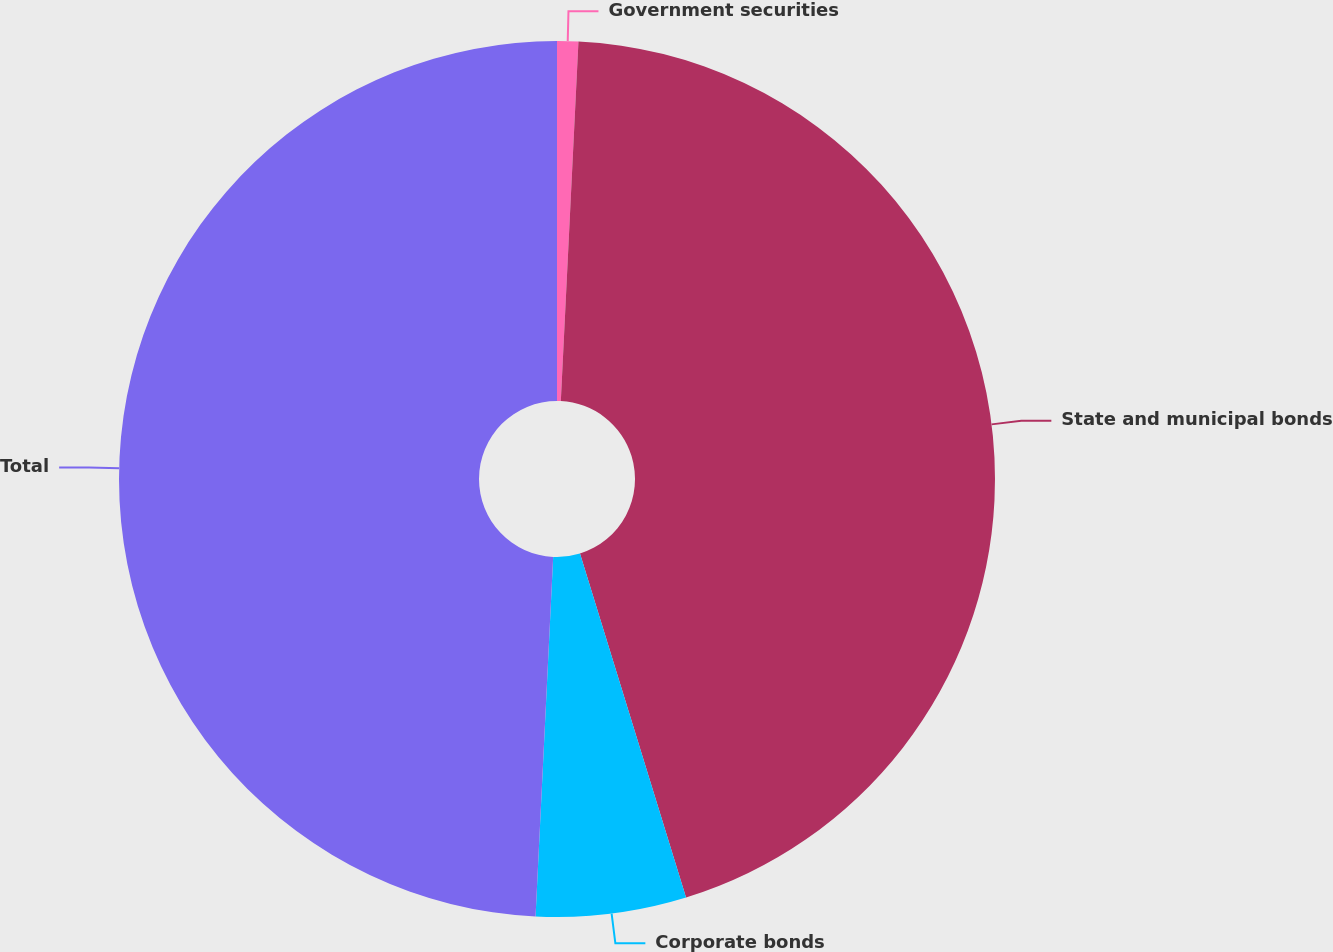<chart> <loc_0><loc_0><loc_500><loc_500><pie_chart><fcel>Government securities<fcel>State and municipal bonds<fcel>Corporate bonds<fcel>Total<nl><fcel>0.78%<fcel>44.46%<fcel>5.54%<fcel>49.22%<nl></chart> 